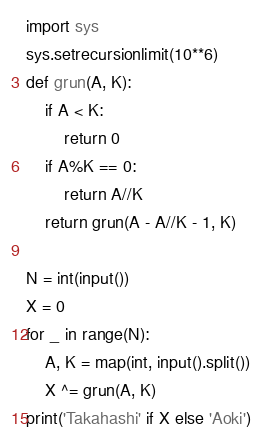<code> <loc_0><loc_0><loc_500><loc_500><_Python_>import sys
sys.setrecursionlimit(10**6)
def grun(A, K):
    if A < K:
        return 0
    if A%K == 0:
        return A//K
    return grun(A - A//K - 1, K)

N = int(input())
X = 0
for _ in range(N):
    A, K = map(int, input().split())
    X ^= grun(A, K)
print('Takahashi' if X else 'Aoki')
</code> 